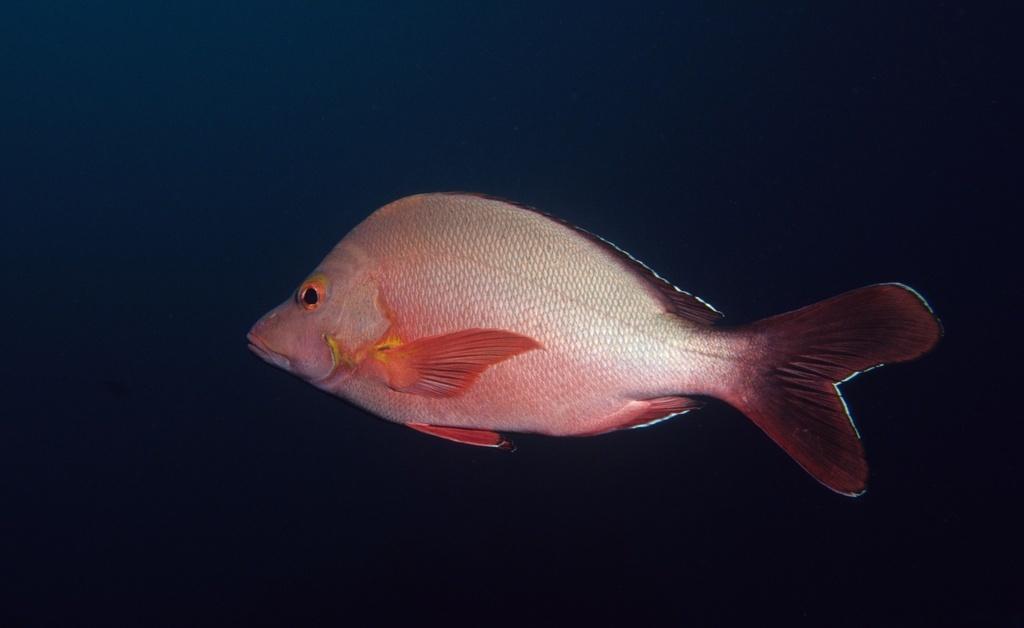Could you give a brief overview of what you see in this image? In this image in the center there is a fish, and and there is a blue background. 